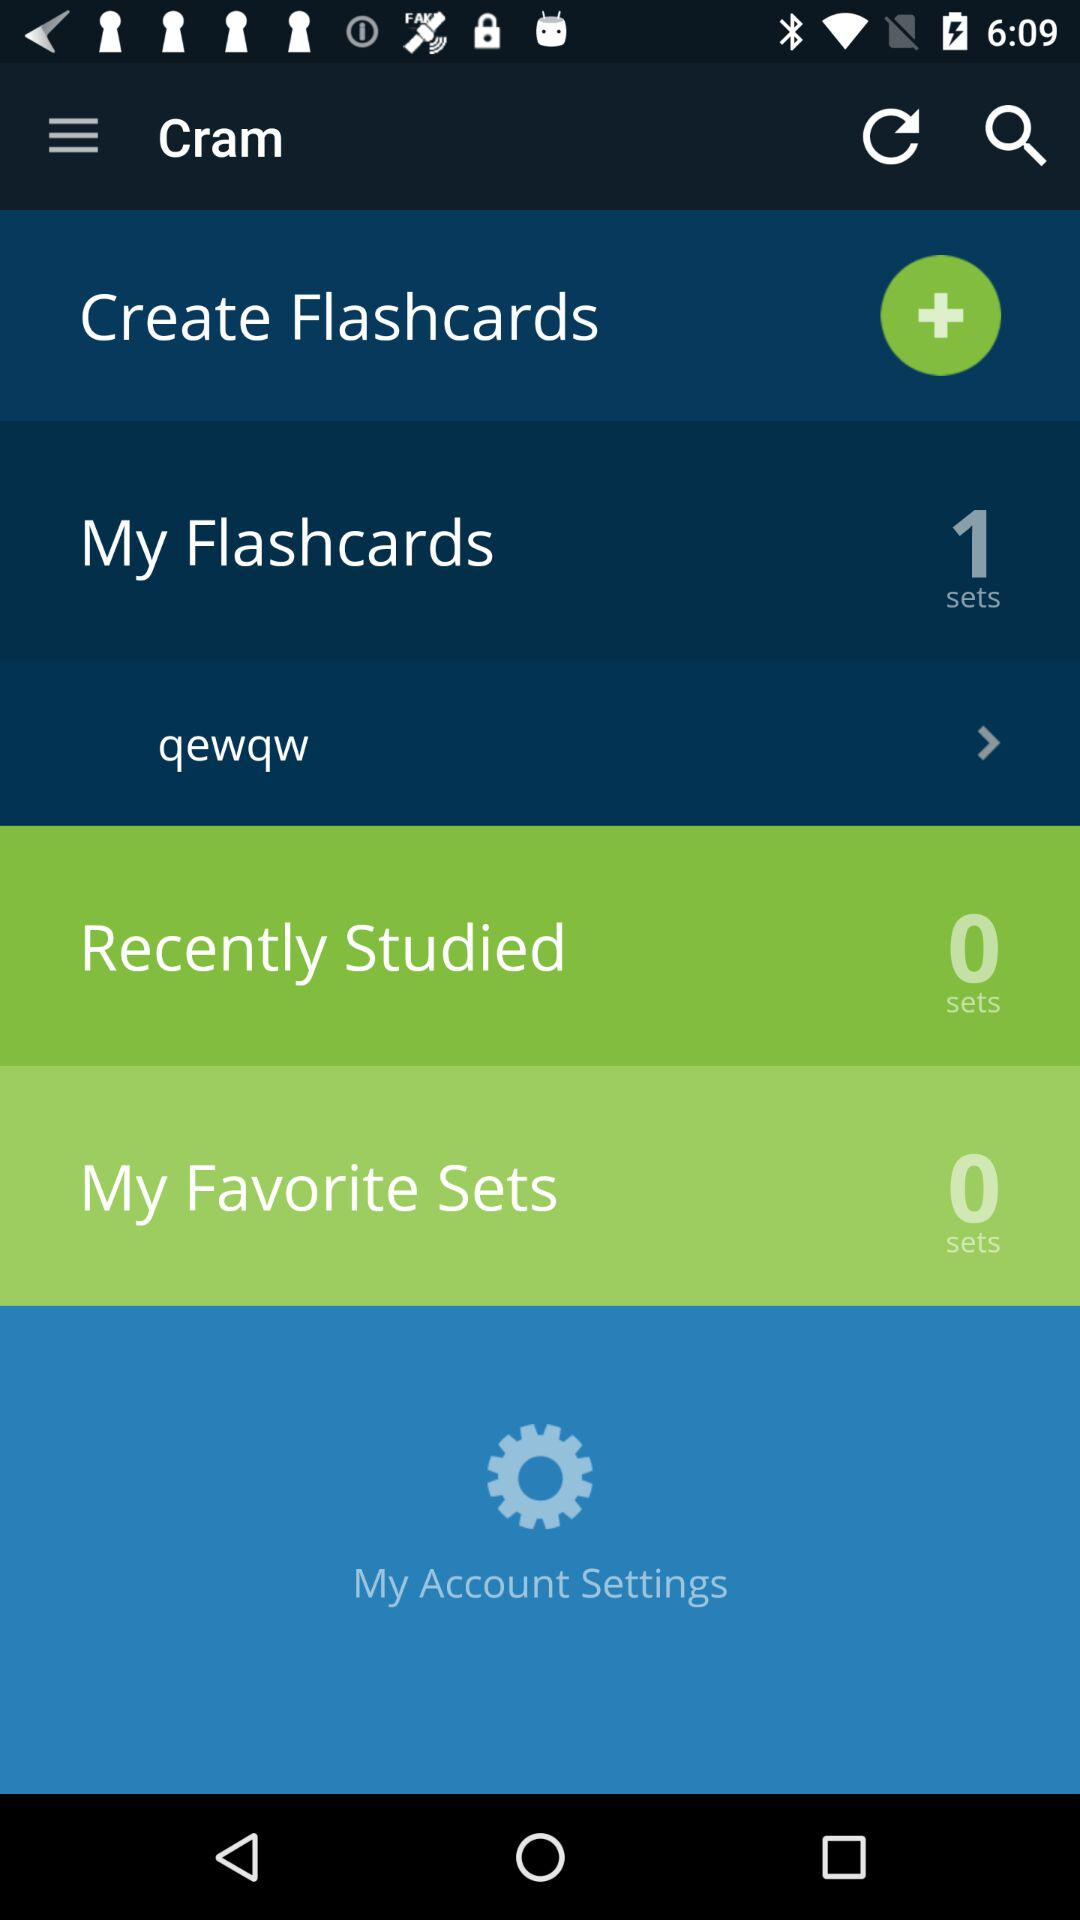How many sets are in the "My Flashcards" section?
Answer the question using a single word or phrase. 1 